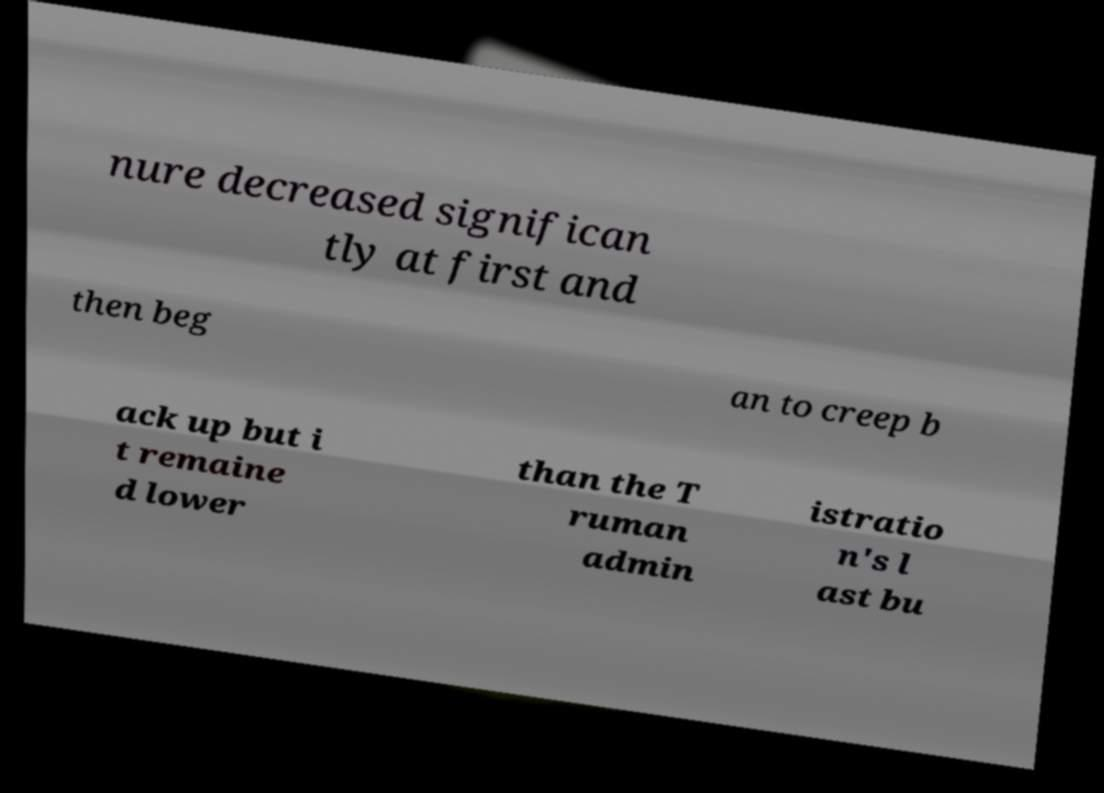Please identify and transcribe the text found in this image. nure decreased significan tly at first and then beg an to creep b ack up but i t remaine d lower than the T ruman admin istratio n's l ast bu 